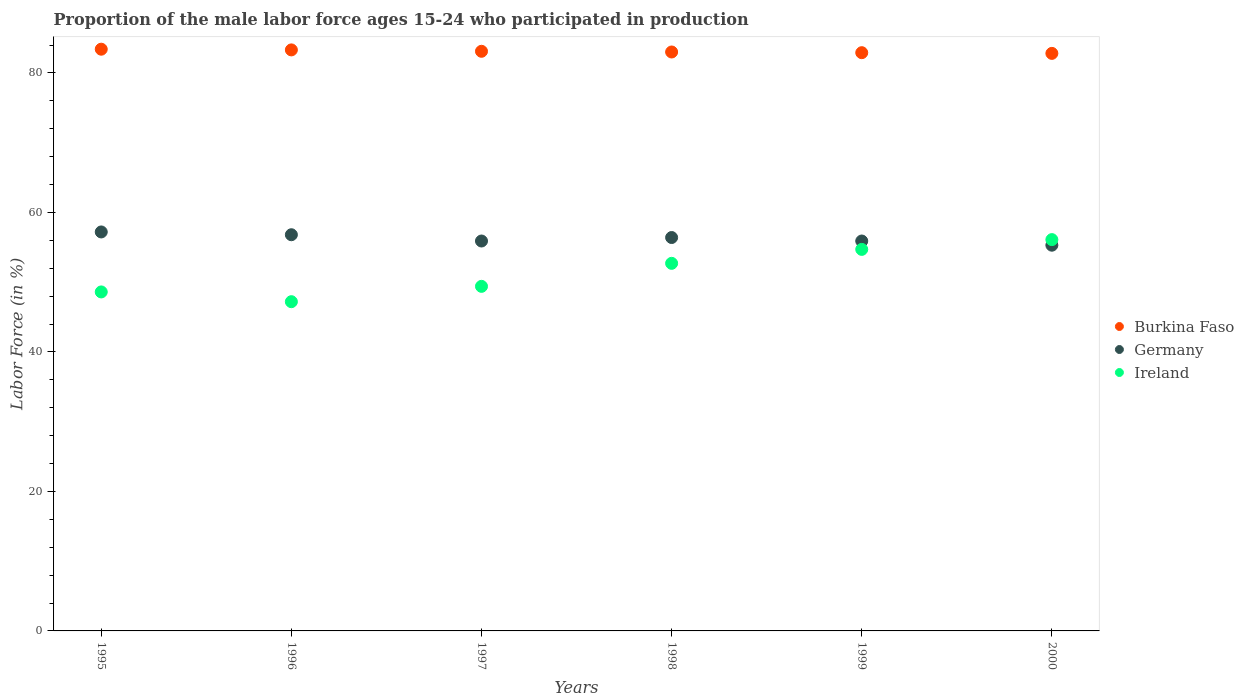How many different coloured dotlines are there?
Provide a short and direct response. 3. Is the number of dotlines equal to the number of legend labels?
Offer a very short reply. Yes. What is the proportion of the male labor force who participated in production in Germany in 1995?
Give a very brief answer. 57.2. Across all years, what is the maximum proportion of the male labor force who participated in production in Burkina Faso?
Give a very brief answer. 83.4. Across all years, what is the minimum proportion of the male labor force who participated in production in Ireland?
Provide a succinct answer. 47.2. In which year was the proportion of the male labor force who participated in production in Burkina Faso minimum?
Provide a short and direct response. 2000. What is the total proportion of the male labor force who participated in production in Germany in the graph?
Make the answer very short. 337.5. What is the difference between the proportion of the male labor force who participated in production in Germany in 1996 and that in 2000?
Offer a terse response. 1.5. What is the difference between the proportion of the male labor force who participated in production in Burkina Faso in 1998 and the proportion of the male labor force who participated in production in Germany in 1995?
Offer a very short reply. 25.8. What is the average proportion of the male labor force who participated in production in Germany per year?
Your response must be concise. 56.25. In the year 1996, what is the difference between the proportion of the male labor force who participated in production in Germany and proportion of the male labor force who participated in production in Ireland?
Provide a succinct answer. 9.6. In how many years, is the proportion of the male labor force who participated in production in Burkina Faso greater than 80 %?
Offer a very short reply. 6. What is the ratio of the proportion of the male labor force who participated in production in Burkina Faso in 1995 to that in 1999?
Ensure brevity in your answer.  1.01. Is the proportion of the male labor force who participated in production in Burkina Faso in 1997 less than that in 1999?
Provide a succinct answer. No. What is the difference between the highest and the second highest proportion of the male labor force who participated in production in Ireland?
Keep it short and to the point. 1.4. What is the difference between the highest and the lowest proportion of the male labor force who participated in production in Burkina Faso?
Provide a short and direct response. 0.6. In how many years, is the proportion of the male labor force who participated in production in Germany greater than the average proportion of the male labor force who participated in production in Germany taken over all years?
Make the answer very short. 3. Is the proportion of the male labor force who participated in production in Ireland strictly greater than the proportion of the male labor force who participated in production in Burkina Faso over the years?
Provide a short and direct response. No. Are the values on the major ticks of Y-axis written in scientific E-notation?
Provide a short and direct response. No. Does the graph contain any zero values?
Your response must be concise. No. How many legend labels are there?
Your answer should be very brief. 3. What is the title of the graph?
Your response must be concise. Proportion of the male labor force ages 15-24 who participated in production. Does "Chad" appear as one of the legend labels in the graph?
Provide a succinct answer. No. What is the label or title of the X-axis?
Give a very brief answer. Years. What is the label or title of the Y-axis?
Provide a succinct answer. Labor Force (in %). What is the Labor Force (in %) in Burkina Faso in 1995?
Make the answer very short. 83.4. What is the Labor Force (in %) in Germany in 1995?
Provide a succinct answer. 57.2. What is the Labor Force (in %) of Ireland in 1995?
Your answer should be compact. 48.6. What is the Labor Force (in %) of Burkina Faso in 1996?
Provide a succinct answer. 83.3. What is the Labor Force (in %) of Germany in 1996?
Provide a succinct answer. 56.8. What is the Labor Force (in %) in Ireland in 1996?
Your answer should be compact. 47.2. What is the Labor Force (in %) of Burkina Faso in 1997?
Provide a succinct answer. 83.1. What is the Labor Force (in %) in Germany in 1997?
Provide a short and direct response. 55.9. What is the Labor Force (in %) in Ireland in 1997?
Provide a succinct answer. 49.4. What is the Labor Force (in %) in Burkina Faso in 1998?
Provide a short and direct response. 83. What is the Labor Force (in %) in Germany in 1998?
Provide a short and direct response. 56.4. What is the Labor Force (in %) in Ireland in 1998?
Your answer should be compact. 52.7. What is the Labor Force (in %) of Burkina Faso in 1999?
Make the answer very short. 82.9. What is the Labor Force (in %) of Germany in 1999?
Give a very brief answer. 55.9. What is the Labor Force (in %) in Ireland in 1999?
Provide a succinct answer. 54.7. What is the Labor Force (in %) in Burkina Faso in 2000?
Offer a very short reply. 82.8. What is the Labor Force (in %) of Germany in 2000?
Keep it short and to the point. 55.3. What is the Labor Force (in %) of Ireland in 2000?
Make the answer very short. 56.1. Across all years, what is the maximum Labor Force (in %) in Burkina Faso?
Give a very brief answer. 83.4. Across all years, what is the maximum Labor Force (in %) in Germany?
Offer a terse response. 57.2. Across all years, what is the maximum Labor Force (in %) in Ireland?
Provide a short and direct response. 56.1. Across all years, what is the minimum Labor Force (in %) in Burkina Faso?
Keep it short and to the point. 82.8. Across all years, what is the minimum Labor Force (in %) in Germany?
Ensure brevity in your answer.  55.3. Across all years, what is the minimum Labor Force (in %) of Ireland?
Provide a short and direct response. 47.2. What is the total Labor Force (in %) in Burkina Faso in the graph?
Give a very brief answer. 498.5. What is the total Labor Force (in %) of Germany in the graph?
Keep it short and to the point. 337.5. What is the total Labor Force (in %) of Ireland in the graph?
Make the answer very short. 308.7. What is the difference between the Labor Force (in %) in Burkina Faso in 1995 and that in 1996?
Ensure brevity in your answer.  0.1. What is the difference between the Labor Force (in %) in Germany in 1995 and that in 1996?
Ensure brevity in your answer.  0.4. What is the difference between the Labor Force (in %) in Ireland in 1995 and that in 1996?
Make the answer very short. 1.4. What is the difference between the Labor Force (in %) of Burkina Faso in 1995 and that in 1997?
Your answer should be very brief. 0.3. What is the difference between the Labor Force (in %) of Ireland in 1995 and that in 1997?
Provide a short and direct response. -0.8. What is the difference between the Labor Force (in %) in Burkina Faso in 1995 and that in 1998?
Keep it short and to the point. 0.4. What is the difference between the Labor Force (in %) of Germany in 1995 and that in 1998?
Your response must be concise. 0.8. What is the difference between the Labor Force (in %) in Burkina Faso in 1995 and that in 1999?
Make the answer very short. 0.5. What is the difference between the Labor Force (in %) of Ireland in 1995 and that in 1999?
Keep it short and to the point. -6.1. What is the difference between the Labor Force (in %) in Burkina Faso in 1996 and that in 1999?
Provide a short and direct response. 0.4. What is the difference between the Labor Force (in %) of Germany in 1996 and that in 1999?
Keep it short and to the point. 0.9. What is the difference between the Labor Force (in %) of Ireland in 1996 and that in 2000?
Keep it short and to the point. -8.9. What is the difference between the Labor Force (in %) of Burkina Faso in 1997 and that in 1998?
Keep it short and to the point. 0.1. What is the difference between the Labor Force (in %) in Burkina Faso in 1997 and that in 1999?
Offer a terse response. 0.2. What is the difference between the Labor Force (in %) in Ireland in 1997 and that in 1999?
Make the answer very short. -5.3. What is the difference between the Labor Force (in %) in Burkina Faso in 1997 and that in 2000?
Keep it short and to the point. 0.3. What is the difference between the Labor Force (in %) of Germany in 1997 and that in 2000?
Make the answer very short. 0.6. What is the difference between the Labor Force (in %) of Germany in 1998 and that in 1999?
Provide a succinct answer. 0.5. What is the difference between the Labor Force (in %) in Ireland in 1998 and that in 1999?
Your answer should be very brief. -2. What is the difference between the Labor Force (in %) in Burkina Faso in 1998 and that in 2000?
Provide a short and direct response. 0.2. What is the difference between the Labor Force (in %) in Germany in 1998 and that in 2000?
Offer a terse response. 1.1. What is the difference between the Labor Force (in %) of Ireland in 1998 and that in 2000?
Provide a succinct answer. -3.4. What is the difference between the Labor Force (in %) in Germany in 1999 and that in 2000?
Make the answer very short. 0.6. What is the difference between the Labor Force (in %) in Ireland in 1999 and that in 2000?
Offer a terse response. -1.4. What is the difference between the Labor Force (in %) of Burkina Faso in 1995 and the Labor Force (in %) of Germany in 1996?
Make the answer very short. 26.6. What is the difference between the Labor Force (in %) in Burkina Faso in 1995 and the Labor Force (in %) in Ireland in 1996?
Your answer should be compact. 36.2. What is the difference between the Labor Force (in %) in Germany in 1995 and the Labor Force (in %) in Ireland in 1996?
Your answer should be compact. 10. What is the difference between the Labor Force (in %) of Germany in 1995 and the Labor Force (in %) of Ireland in 1997?
Ensure brevity in your answer.  7.8. What is the difference between the Labor Force (in %) of Burkina Faso in 1995 and the Labor Force (in %) of Ireland in 1998?
Your answer should be compact. 30.7. What is the difference between the Labor Force (in %) of Burkina Faso in 1995 and the Labor Force (in %) of Ireland in 1999?
Your answer should be compact. 28.7. What is the difference between the Labor Force (in %) in Burkina Faso in 1995 and the Labor Force (in %) in Germany in 2000?
Your answer should be very brief. 28.1. What is the difference between the Labor Force (in %) of Burkina Faso in 1995 and the Labor Force (in %) of Ireland in 2000?
Offer a terse response. 27.3. What is the difference between the Labor Force (in %) in Germany in 1995 and the Labor Force (in %) in Ireland in 2000?
Your response must be concise. 1.1. What is the difference between the Labor Force (in %) of Burkina Faso in 1996 and the Labor Force (in %) of Germany in 1997?
Offer a very short reply. 27.4. What is the difference between the Labor Force (in %) in Burkina Faso in 1996 and the Labor Force (in %) in Ireland in 1997?
Provide a succinct answer. 33.9. What is the difference between the Labor Force (in %) in Germany in 1996 and the Labor Force (in %) in Ireland in 1997?
Your answer should be compact. 7.4. What is the difference between the Labor Force (in %) in Burkina Faso in 1996 and the Labor Force (in %) in Germany in 1998?
Your answer should be very brief. 26.9. What is the difference between the Labor Force (in %) of Burkina Faso in 1996 and the Labor Force (in %) of Ireland in 1998?
Provide a succinct answer. 30.6. What is the difference between the Labor Force (in %) in Burkina Faso in 1996 and the Labor Force (in %) in Germany in 1999?
Your response must be concise. 27.4. What is the difference between the Labor Force (in %) of Burkina Faso in 1996 and the Labor Force (in %) of Ireland in 1999?
Your answer should be compact. 28.6. What is the difference between the Labor Force (in %) in Burkina Faso in 1996 and the Labor Force (in %) in Ireland in 2000?
Provide a succinct answer. 27.2. What is the difference between the Labor Force (in %) in Germany in 1996 and the Labor Force (in %) in Ireland in 2000?
Provide a succinct answer. 0.7. What is the difference between the Labor Force (in %) of Burkina Faso in 1997 and the Labor Force (in %) of Germany in 1998?
Your answer should be very brief. 26.7. What is the difference between the Labor Force (in %) of Burkina Faso in 1997 and the Labor Force (in %) of Ireland in 1998?
Make the answer very short. 30.4. What is the difference between the Labor Force (in %) in Burkina Faso in 1997 and the Labor Force (in %) in Germany in 1999?
Offer a terse response. 27.2. What is the difference between the Labor Force (in %) in Burkina Faso in 1997 and the Labor Force (in %) in Ireland in 1999?
Give a very brief answer. 28.4. What is the difference between the Labor Force (in %) in Burkina Faso in 1997 and the Labor Force (in %) in Germany in 2000?
Your answer should be compact. 27.8. What is the difference between the Labor Force (in %) of Germany in 1997 and the Labor Force (in %) of Ireland in 2000?
Your answer should be compact. -0.2. What is the difference between the Labor Force (in %) of Burkina Faso in 1998 and the Labor Force (in %) of Germany in 1999?
Keep it short and to the point. 27.1. What is the difference between the Labor Force (in %) of Burkina Faso in 1998 and the Labor Force (in %) of Ireland in 1999?
Provide a succinct answer. 28.3. What is the difference between the Labor Force (in %) of Burkina Faso in 1998 and the Labor Force (in %) of Germany in 2000?
Offer a very short reply. 27.7. What is the difference between the Labor Force (in %) of Burkina Faso in 1998 and the Labor Force (in %) of Ireland in 2000?
Offer a very short reply. 26.9. What is the difference between the Labor Force (in %) in Germany in 1998 and the Labor Force (in %) in Ireland in 2000?
Your response must be concise. 0.3. What is the difference between the Labor Force (in %) in Burkina Faso in 1999 and the Labor Force (in %) in Germany in 2000?
Provide a succinct answer. 27.6. What is the difference between the Labor Force (in %) of Burkina Faso in 1999 and the Labor Force (in %) of Ireland in 2000?
Provide a short and direct response. 26.8. What is the difference between the Labor Force (in %) of Germany in 1999 and the Labor Force (in %) of Ireland in 2000?
Provide a succinct answer. -0.2. What is the average Labor Force (in %) in Burkina Faso per year?
Offer a very short reply. 83.08. What is the average Labor Force (in %) in Germany per year?
Provide a short and direct response. 56.25. What is the average Labor Force (in %) of Ireland per year?
Your answer should be compact. 51.45. In the year 1995, what is the difference between the Labor Force (in %) of Burkina Faso and Labor Force (in %) of Germany?
Give a very brief answer. 26.2. In the year 1995, what is the difference between the Labor Force (in %) of Burkina Faso and Labor Force (in %) of Ireland?
Provide a succinct answer. 34.8. In the year 1996, what is the difference between the Labor Force (in %) in Burkina Faso and Labor Force (in %) in Germany?
Make the answer very short. 26.5. In the year 1996, what is the difference between the Labor Force (in %) in Burkina Faso and Labor Force (in %) in Ireland?
Provide a short and direct response. 36.1. In the year 1996, what is the difference between the Labor Force (in %) in Germany and Labor Force (in %) in Ireland?
Ensure brevity in your answer.  9.6. In the year 1997, what is the difference between the Labor Force (in %) of Burkina Faso and Labor Force (in %) of Germany?
Your answer should be very brief. 27.2. In the year 1997, what is the difference between the Labor Force (in %) in Burkina Faso and Labor Force (in %) in Ireland?
Ensure brevity in your answer.  33.7. In the year 1997, what is the difference between the Labor Force (in %) in Germany and Labor Force (in %) in Ireland?
Your answer should be very brief. 6.5. In the year 1998, what is the difference between the Labor Force (in %) in Burkina Faso and Labor Force (in %) in Germany?
Ensure brevity in your answer.  26.6. In the year 1998, what is the difference between the Labor Force (in %) in Burkina Faso and Labor Force (in %) in Ireland?
Offer a very short reply. 30.3. In the year 1998, what is the difference between the Labor Force (in %) of Germany and Labor Force (in %) of Ireland?
Ensure brevity in your answer.  3.7. In the year 1999, what is the difference between the Labor Force (in %) of Burkina Faso and Labor Force (in %) of Ireland?
Offer a very short reply. 28.2. In the year 1999, what is the difference between the Labor Force (in %) in Germany and Labor Force (in %) in Ireland?
Your response must be concise. 1.2. In the year 2000, what is the difference between the Labor Force (in %) of Burkina Faso and Labor Force (in %) of Germany?
Offer a terse response. 27.5. In the year 2000, what is the difference between the Labor Force (in %) in Burkina Faso and Labor Force (in %) in Ireland?
Offer a very short reply. 26.7. What is the ratio of the Labor Force (in %) of Burkina Faso in 1995 to that in 1996?
Your response must be concise. 1. What is the ratio of the Labor Force (in %) of Germany in 1995 to that in 1996?
Your answer should be compact. 1.01. What is the ratio of the Labor Force (in %) of Ireland in 1995 to that in 1996?
Offer a terse response. 1.03. What is the ratio of the Labor Force (in %) of Germany in 1995 to that in 1997?
Make the answer very short. 1.02. What is the ratio of the Labor Force (in %) in Ireland in 1995 to that in 1997?
Make the answer very short. 0.98. What is the ratio of the Labor Force (in %) in Burkina Faso in 1995 to that in 1998?
Provide a short and direct response. 1. What is the ratio of the Labor Force (in %) of Germany in 1995 to that in 1998?
Offer a very short reply. 1.01. What is the ratio of the Labor Force (in %) in Ireland in 1995 to that in 1998?
Keep it short and to the point. 0.92. What is the ratio of the Labor Force (in %) in Burkina Faso in 1995 to that in 1999?
Offer a terse response. 1.01. What is the ratio of the Labor Force (in %) in Germany in 1995 to that in 1999?
Provide a succinct answer. 1.02. What is the ratio of the Labor Force (in %) of Ireland in 1995 to that in 1999?
Give a very brief answer. 0.89. What is the ratio of the Labor Force (in %) of Burkina Faso in 1995 to that in 2000?
Offer a terse response. 1.01. What is the ratio of the Labor Force (in %) in Germany in 1995 to that in 2000?
Keep it short and to the point. 1.03. What is the ratio of the Labor Force (in %) of Ireland in 1995 to that in 2000?
Your response must be concise. 0.87. What is the ratio of the Labor Force (in %) in Germany in 1996 to that in 1997?
Give a very brief answer. 1.02. What is the ratio of the Labor Force (in %) of Ireland in 1996 to that in 1997?
Your answer should be very brief. 0.96. What is the ratio of the Labor Force (in %) of Germany in 1996 to that in 1998?
Your answer should be compact. 1.01. What is the ratio of the Labor Force (in %) in Ireland in 1996 to that in 1998?
Keep it short and to the point. 0.9. What is the ratio of the Labor Force (in %) in Burkina Faso in 1996 to that in 1999?
Give a very brief answer. 1. What is the ratio of the Labor Force (in %) in Germany in 1996 to that in 1999?
Provide a succinct answer. 1.02. What is the ratio of the Labor Force (in %) in Ireland in 1996 to that in 1999?
Keep it short and to the point. 0.86. What is the ratio of the Labor Force (in %) in Burkina Faso in 1996 to that in 2000?
Provide a short and direct response. 1.01. What is the ratio of the Labor Force (in %) of Germany in 1996 to that in 2000?
Offer a very short reply. 1.03. What is the ratio of the Labor Force (in %) of Ireland in 1996 to that in 2000?
Your response must be concise. 0.84. What is the ratio of the Labor Force (in %) of Germany in 1997 to that in 1998?
Your response must be concise. 0.99. What is the ratio of the Labor Force (in %) of Ireland in 1997 to that in 1998?
Offer a very short reply. 0.94. What is the ratio of the Labor Force (in %) of Ireland in 1997 to that in 1999?
Provide a short and direct response. 0.9. What is the ratio of the Labor Force (in %) in Germany in 1997 to that in 2000?
Your response must be concise. 1.01. What is the ratio of the Labor Force (in %) in Ireland in 1997 to that in 2000?
Ensure brevity in your answer.  0.88. What is the ratio of the Labor Force (in %) of Burkina Faso in 1998 to that in 1999?
Ensure brevity in your answer.  1. What is the ratio of the Labor Force (in %) of Germany in 1998 to that in 1999?
Make the answer very short. 1.01. What is the ratio of the Labor Force (in %) of Ireland in 1998 to that in 1999?
Your answer should be compact. 0.96. What is the ratio of the Labor Force (in %) of Germany in 1998 to that in 2000?
Make the answer very short. 1.02. What is the ratio of the Labor Force (in %) of Ireland in 1998 to that in 2000?
Give a very brief answer. 0.94. What is the ratio of the Labor Force (in %) in Germany in 1999 to that in 2000?
Your answer should be very brief. 1.01. What is the ratio of the Labor Force (in %) of Ireland in 1999 to that in 2000?
Make the answer very short. 0.97. What is the difference between the highest and the second highest Labor Force (in %) of Germany?
Keep it short and to the point. 0.4. What is the difference between the highest and the second highest Labor Force (in %) in Ireland?
Your answer should be very brief. 1.4. What is the difference between the highest and the lowest Labor Force (in %) of Ireland?
Your answer should be very brief. 8.9. 